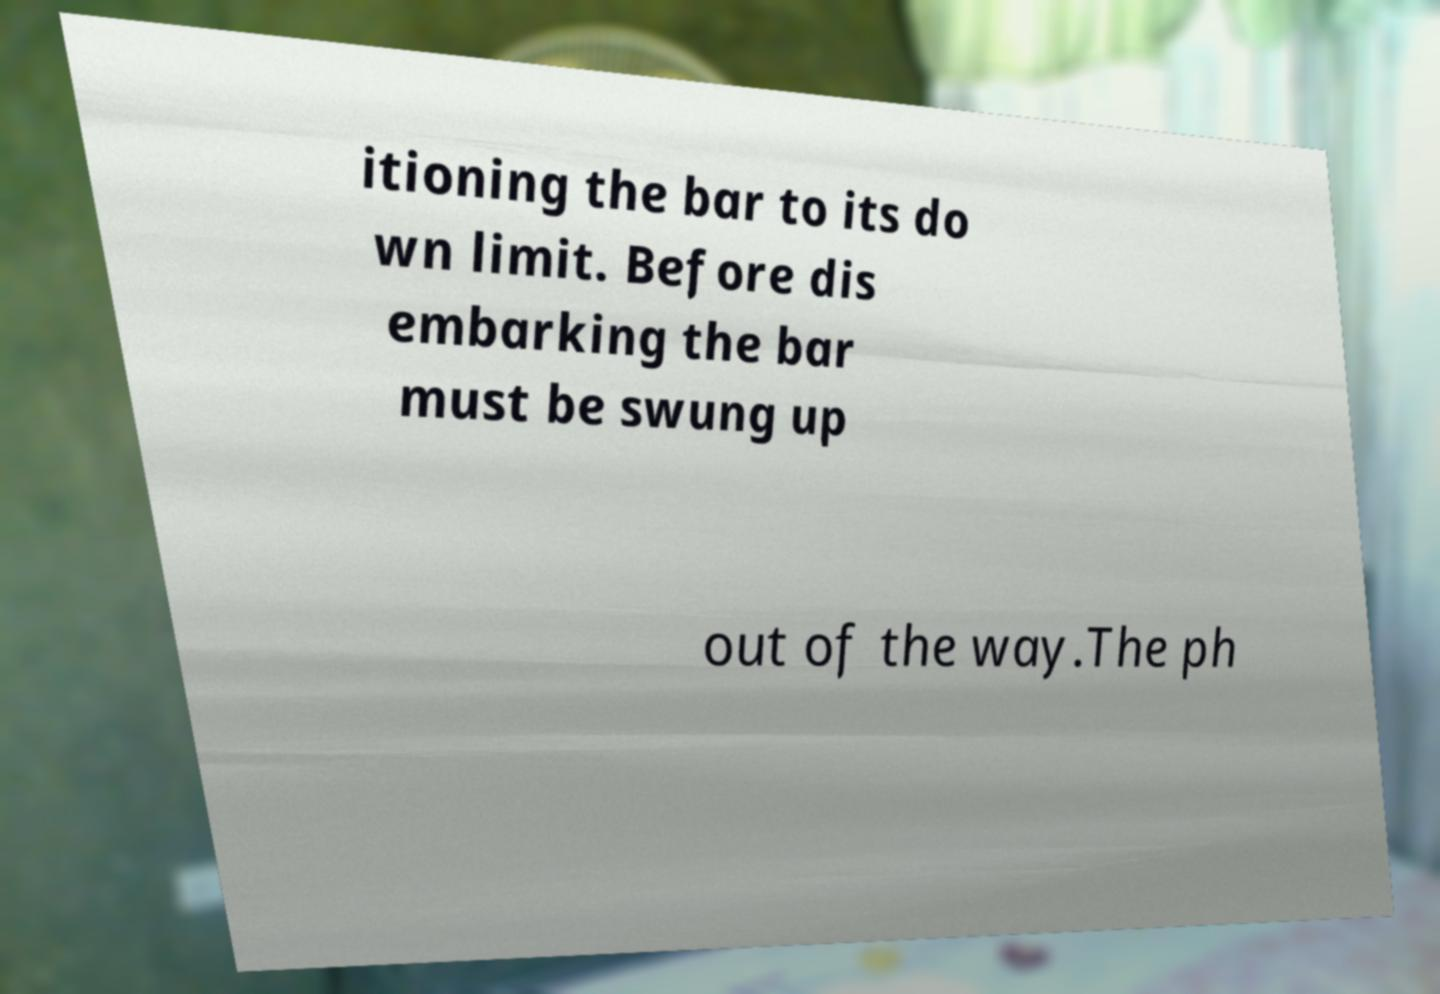Please identify and transcribe the text found in this image. itioning the bar to its do wn limit. Before dis embarking the bar must be swung up out of the way.The ph 